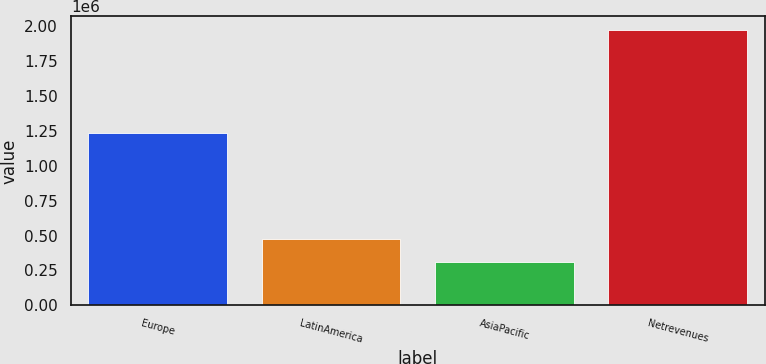<chart> <loc_0><loc_0><loc_500><loc_500><bar_chart><fcel>Europe<fcel>LatinAmerica<fcel>AsiaPacific<fcel>Netrevenues<nl><fcel>1.23685e+06<fcel>475216<fcel>308920<fcel>1.97188e+06<nl></chart> 